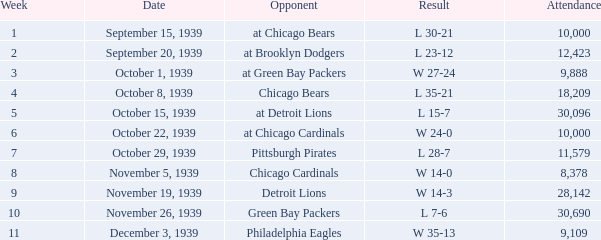Which Week has a Result of w 24-0, and an Attendance smaller than 10,000? None. 